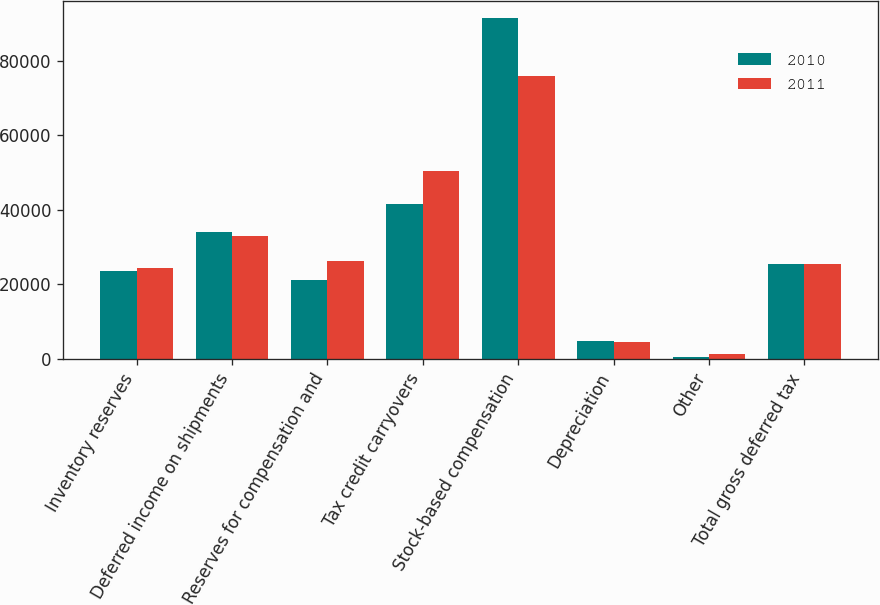<chart> <loc_0><loc_0><loc_500><loc_500><stacked_bar_chart><ecel><fcel>Inventory reserves<fcel>Deferred income on shipments<fcel>Reserves for compensation and<fcel>Tax credit carryovers<fcel>Stock-based compensation<fcel>Depreciation<fcel>Other<fcel>Total gross deferred tax<nl><fcel>2010<fcel>23503<fcel>34061<fcel>21164<fcel>41468<fcel>91417<fcel>4781<fcel>592<fcel>25347<nl><fcel>2011<fcel>24495<fcel>32870<fcel>26199<fcel>50384<fcel>75827<fcel>4553<fcel>1251<fcel>25347<nl></chart> 